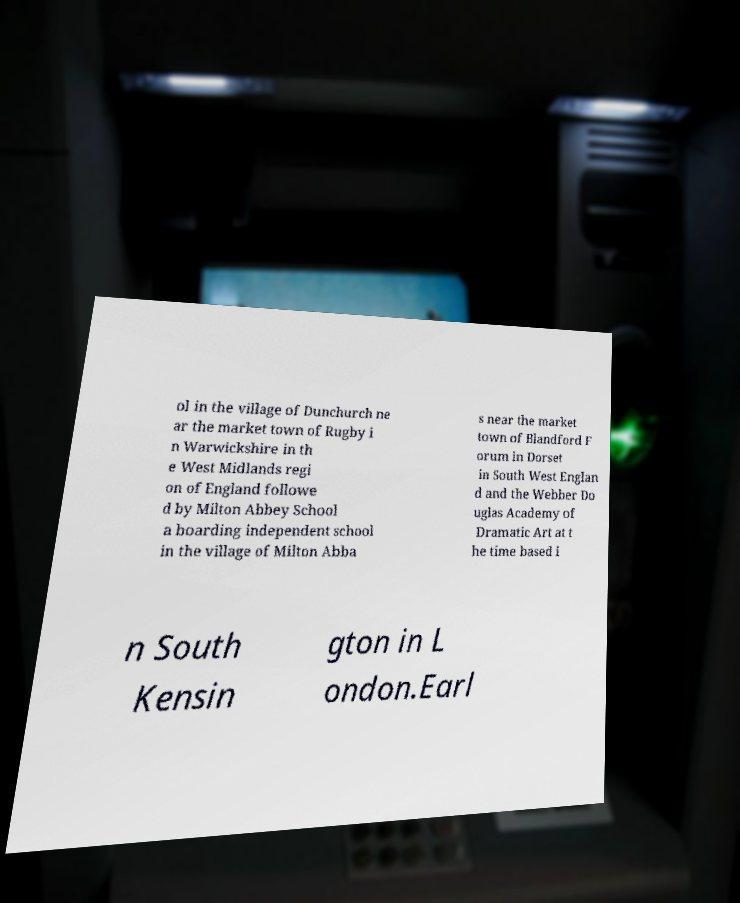What messages or text are displayed in this image? I need them in a readable, typed format. ol in the village of Dunchurch ne ar the market town of Rugby i n Warwickshire in th e West Midlands regi on of England followe d by Milton Abbey School a boarding independent school in the village of Milton Abba s near the market town of Blandford F orum in Dorset in South West Englan d and the Webber Do uglas Academy of Dramatic Art at t he time based i n South Kensin gton in L ondon.Earl 